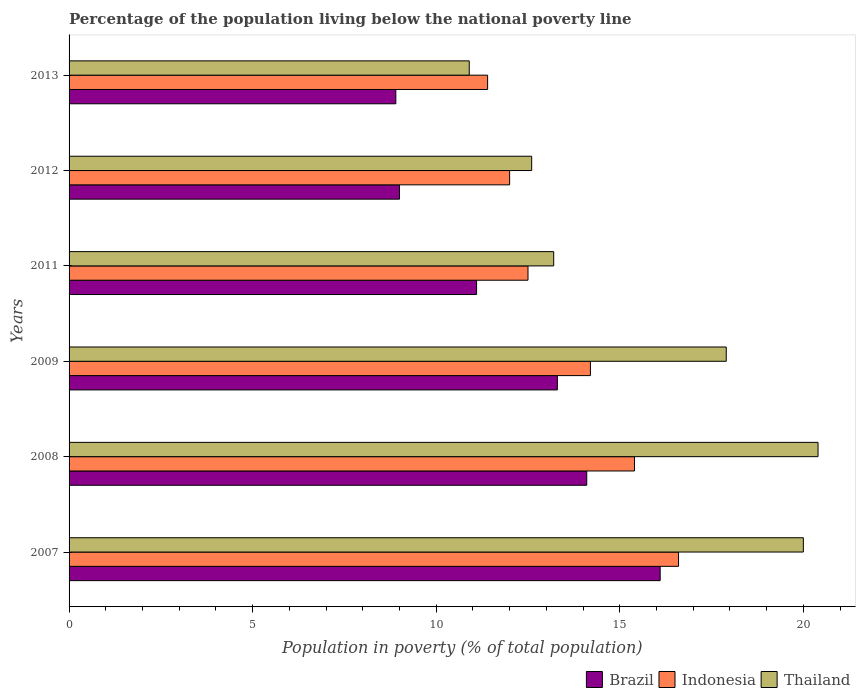Are the number of bars per tick equal to the number of legend labels?
Provide a succinct answer. Yes. How many bars are there on the 1st tick from the bottom?
Ensure brevity in your answer.  3. In how many cases, is the number of bars for a given year not equal to the number of legend labels?
Your response must be concise. 0. What is the percentage of the population living below the national poverty line in Thailand in 2009?
Make the answer very short. 17.9. Across all years, what is the maximum percentage of the population living below the national poverty line in Brazil?
Your answer should be very brief. 16.1. Across all years, what is the minimum percentage of the population living below the national poverty line in Indonesia?
Offer a very short reply. 11.4. In which year was the percentage of the population living below the national poverty line in Brazil minimum?
Provide a short and direct response. 2013. What is the difference between the percentage of the population living below the national poverty line in Indonesia in 2009 and that in 2012?
Ensure brevity in your answer.  2.2. What is the difference between the percentage of the population living below the national poverty line in Brazil in 2008 and the percentage of the population living below the national poverty line in Indonesia in 2012?
Your answer should be compact. 2.1. What is the average percentage of the population living below the national poverty line in Brazil per year?
Your answer should be very brief. 12.08. What is the ratio of the percentage of the population living below the national poverty line in Thailand in 2007 to that in 2008?
Offer a very short reply. 0.98. Is the percentage of the population living below the national poverty line in Thailand in 2012 less than that in 2013?
Give a very brief answer. No. What is the difference between the highest and the second highest percentage of the population living below the national poverty line in Thailand?
Provide a short and direct response. 0.4. What is the difference between the highest and the lowest percentage of the population living below the national poverty line in Thailand?
Give a very brief answer. 9.5. What does the 2nd bar from the top in 2012 represents?
Ensure brevity in your answer.  Indonesia. What does the 3rd bar from the bottom in 2008 represents?
Keep it short and to the point. Thailand. Is it the case that in every year, the sum of the percentage of the population living below the national poverty line in Brazil and percentage of the population living below the national poverty line in Thailand is greater than the percentage of the population living below the national poverty line in Indonesia?
Your answer should be compact. Yes. How many bars are there?
Your answer should be compact. 18. How many years are there in the graph?
Your answer should be very brief. 6. What is the difference between two consecutive major ticks on the X-axis?
Keep it short and to the point. 5. Are the values on the major ticks of X-axis written in scientific E-notation?
Ensure brevity in your answer.  No. What is the title of the graph?
Offer a very short reply. Percentage of the population living below the national poverty line. What is the label or title of the X-axis?
Your answer should be compact. Population in poverty (% of total population). What is the label or title of the Y-axis?
Your answer should be compact. Years. What is the Population in poverty (% of total population) in Indonesia in 2007?
Provide a short and direct response. 16.6. What is the Population in poverty (% of total population) of Thailand in 2008?
Keep it short and to the point. 20.4. What is the Population in poverty (% of total population) of Brazil in 2009?
Offer a very short reply. 13.3. What is the Population in poverty (% of total population) in Brazil in 2011?
Give a very brief answer. 11.1. What is the Population in poverty (% of total population) in Indonesia in 2011?
Provide a succinct answer. 12.5. What is the Population in poverty (% of total population) of Thailand in 2011?
Your answer should be compact. 13.2. What is the Population in poverty (% of total population) in Brazil in 2012?
Your answer should be compact. 9. What is the Population in poverty (% of total population) in Indonesia in 2012?
Ensure brevity in your answer.  12. What is the Population in poverty (% of total population) in Thailand in 2012?
Offer a very short reply. 12.6. Across all years, what is the maximum Population in poverty (% of total population) of Brazil?
Keep it short and to the point. 16.1. Across all years, what is the maximum Population in poverty (% of total population) of Thailand?
Provide a short and direct response. 20.4. Across all years, what is the minimum Population in poverty (% of total population) of Brazil?
Your answer should be compact. 8.9. What is the total Population in poverty (% of total population) of Brazil in the graph?
Keep it short and to the point. 72.5. What is the total Population in poverty (% of total population) in Indonesia in the graph?
Your answer should be compact. 82.1. What is the total Population in poverty (% of total population) in Thailand in the graph?
Offer a very short reply. 95. What is the difference between the Population in poverty (% of total population) of Brazil in 2007 and that in 2008?
Give a very brief answer. 2. What is the difference between the Population in poverty (% of total population) in Indonesia in 2007 and that in 2008?
Give a very brief answer. 1.2. What is the difference between the Population in poverty (% of total population) in Brazil in 2007 and that in 2009?
Your response must be concise. 2.8. What is the difference between the Population in poverty (% of total population) in Indonesia in 2007 and that in 2009?
Provide a succinct answer. 2.4. What is the difference between the Population in poverty (% of total population) in Thailand in 2007 and that in 2009?
Offer a very short reply. 2.1. What is the difference between the Population in poverty (% of total population) in Brazil in 2007 and that in 2011?
Ensure brevity in your answer.  5. What is the difference between the Population in poverty (% of total population) in Indonesia in 2007 and that in 2011?
Keep it short and to the point. 4.1. What is the difference between the Population in poverty (% of total population) in Indonesia in 2007 and that in 2012?
Your answer should be very brief. 4.6. What is the difference between the Population in poverty (% of total population) in Thailand in 2007 and that in 2012?
Your answer should be compact. 7.4. What is the difference between the Population in poverty (% of total population) in Brazil in 2008 and that in 2009?
Give a very brief answer. 0.8. What is the difference between the Population in poverty (% of total population) in Brazil in 2008 and that in 2012?
Make the answer very short. 5.1. What is the difference between the Population in poverty (% of total population) of Indonesia in 2008 and that in 2012?
Offer a terse response. 3.4. What is the difference between the Population in poverty (% of total population) of Thailand in 2008 and that in 2012?
Offer a very short reply. 7.8. What is the difference between the Population in poverty (% of total population) in Brazil in 2008 and that in 2013?
Your answer should be compact. 5.2. What is the difference between the Population in poverty (% of total population) of Thailand in 2008 and that in 2013?
Make the answer very short. 9.5. What is the difference between the Population in poverty (% of total population) of Indonesia in 2009 and that in 2011?
Your response must be concise. 1.7. What is the difference between the Population in poverty (% of total population) of Brazil in 2009 and that in 2013?
Make the answer very short. 4.4. What is the difference between the Population in poverty (% of total population) in Indonesia in 2009 and that in 2013?
Keep it short and to the point. 2.8. What is the difference between the Population in poverty (% of total population) in Thailand in 2009 and that in 2013?
Your answer should be very brief. 7. What is the difference between the Population in poverty (% of total population) in Brazil in 2011 and that in 2013?
Provide a short and direct response. 2.2. What is the difference between the Population in poverty (% of total population) in Indonesia in 2011 and that in 2013?
Make the answer very short. 1.1. What is the difference between the Population in poverty (% of total population) of Indonesia in 2012 and that in 2013?
Ensure brevity in your answer.  0.6. What is the difference between the Population in poverty (% of total population) of Thailand in 2012 and that in 2013?
Provide a short and direct response. 1.7. What is the difference between the Population in poverty (% of total population) in Brazil in 2007 and the Population in poverty (% of total population) in Indonesia in 2008?
Your answer should be very brief. 0.7. What is the difference between the Population in poverty (% of total population) in Indonesia in 2007 and the Population in poverty (% of total population) in Thailand in 2008?
Make the answer very short. -3.8. What is the difference between the Population in poverty (% of total population) in Indonesia in 2007 and the Population in poverty (% of total population) in Thailand in 2009?
Your response must be concise. -1.3. What is the difference between the Population in poverty (% of total population) of Brazil in 2007 and the Population in poverty (% of total population) of Thailand in 2011?
Provide a succinct answer. 2.9. What is the difference between the Population in poverty (% of total population) of Brazil in 2007 and the Population in poverty (% of total population) of Thailand in 2012?
Ensure brevity in your answer.  3.5. What is the difference between the Population in poverty (% of total population) in Brazil in 2008 and the Population in poverty (% of total population) in Thailand in 2009?
Offer a very short reply. -3.8. What is the difference between the Population in poverty (% of total population) in Indonesia in 2008 and the Population in poverty (% of total population) in Thailand in 2011?
Keep it short and to the point. 2.2. What is the difference between the Population in poverty (% of total population) of Brazil in 2008 and the Population in poverty (% of total population) of Thailand in 2012?
Make the answer very short. 1.5. What is the difference between the Population in poverty (% of total population) of Brazil in 2008 and the Population in poverty (% of total population) of Thailand in 2013?
Provide a succinct answer. 3.2. What is the difference between the Population in poverty (% of total population) of Brazil in 2009 and the Population in poverty (% of total population) of Indonesia in 2011?
Your response must be concise. 0.8. What is the difference between the Population in poverty (% of total population) in Brazil in 2009 and the Population in poverty (% of total population) in Thailand in 2011?
Your answer should be very brief. 0.1. What is the difference between the Population in poverty (% of total population) in Indonesia in 2009 and the Population in poverty (% of total population) in Thailand in 2011?
Offer a very short reply. 1. What is the difference between the Population in poverty (% of total population) in Indonesia in 2009 and the Population in poverty (% of total population) in Thailand in 2012?
Offer a terse response. 1.6. What is the difference between the Population in poverty (% of total population) of Indonesia in 2009 and the Population in poverty (% of total population) of Thailand in 2013?
Your answer should be very brief. 3.3. What is the difference between the Population in poverty (% of total population) in Brazil in 2011 and the Population in poverty (% of total population) in Thailand in 2012?
Keep it short and to the point. -1.5. What is the difference between the Population in poverty (% of total population) in Brazil in 2011 and the Population in poverty (% of total population) in Indonesia in 2013?
Your answer should be compact. -0.3. What is the difference between the Population in poverty (% of total population) of Brazil in 2011 and the Population in poverty (% of total population) of Thailand in 2013?
Offer a very short reply. 0.2. What is the difference between the Population in poverty (% of total population) of Indonesia in 2011 and the Population in poverty (% of total population) of Thailand in 2013?
Ensure brevity in your answer.  1.6. What is the difference between the Population in poverty (% of total population) of Brazil in 2012 and the Population in poverty (% of total population) of Indonesia in 2013?
Keep it short and to the point. -2.4. What is the difference between the Population in poverty (% of total population) in Brazil in 2012 and the Population in poverty (% of total population) in Thailand in 2013?
Ensure brevity in your answer.  -1.9. What is the difference between the Population in poverty (% of total population) in Indonesia in 2012 and the Population in poverty (% of total population) in Thailand in 2013?
Provide a succinct answer. 1.1. What is the average Population in poverty (% of total population) of Brazil per year?
Your answer should be compact. 12.08. What is the average Population in poverty (% of total population) of Indonesia per year?
Make the answer very short. 13.68. What is the average Population in poverty (% of total population) of Thailand per year?
Keep it short and to the point. 15.83. In the year 2007, what is the difference between the Population in poverty (% of total population) in Brazil and Population in poverty (% of total population) in Indonesia?
Keep it short and to the point. -0.5. In the year 2008, what is the difference between the Population in poverty (% of total population) in Brazil and Population in poverty (% of total population) in Indonesia?
Provide a succinct answer. -1.3. In the year 2008, what is the difference between the Population in poverty (% of total population) of Brazil and Population in poverty (% of total population) of Thailand?
Ensure brevity in your answer.  -6.3. In the year 2009, what is the difference between the Population in poverty (% of total population) in Brazil and Population in poverty (% of total population) in Indonesia?
Provide a short and direct response. -0.9. In the year 2009, what is the difference between the Population in poverty (% of total population) of Brazil and Population in poverty (% of total population) of Thailand?
Offer a very short reply. -4.6. In the year 2009, what is the difference between the Population in poverty (% of total population) of Indonesia and Population in poverty (% of total population) of Thailand?
Keep it short and to the point. -3.7. In the year 2011, what is the difference between the Population in poverty (% of total population) of Brazil and Population in poverty (% of total population) of Indonesia?
Offer a very short reply. -1.4. In the year 2011, what is the difference between the Population in poverty (% of total population) of Indonesia and Population in poverty (% of total population) of Thailand?
Your response must be concise. -0.7. In the year 2012, what is the difference between the Population in poverty (% of total population) of Brazil and Population in poverty (% of total population) of Thailand?
Provide a short and direct response. -3.6. In the year 2012, what is the difference between the Population in poverty (% of total population) of Indonesia and Population in poverty (% of total population) of Thailand?
Offer a terse response. -0.6. In the year 2013, what is the difference between the Population in poverty (% of total population) in Brazil and Population in poverty (% of total population) in Indonesia?
Your response must be concise. -2.5. In the year 2013, what is the difference between the Population in poverty (% of total population) of Brazil and Population in poverty (% of total population) of Thailand?
Give a very brief answer. -2. What is the ratio of the Population in poverty (% of total population) in Brazil in 2007 to that in 2008?
Offer a very short reply. 1.14. What is the ratio of the Population in poverty (% of total population) of Indonesia in 2007 to that in 2008?
Your answer should be compact. 1.08. What is the ratio of the Population in poverty (% of total population) in Thailand in 2007 to that in 2008?
Offer a terse response. 0.98. What is the ratio of the Population in poverty (% of total population) in Brazil in 2007 to that in 2009?
Your answer should be very brief. 1.21. What is the ratio of the Population in poverty (% of total population) of Indonesia in 2007 to that in 2009?
Ensure brevity in your answer.  1.17. What is the ratio of the Population in poverty (% of total population) of Thailand in 2007 to that in 2009?
Give a very brief answer. 1.12. What is the ratio of the Population in poverty (% of total population) of Brazil in 2007 to that in 2011?
Give a very brief answer. 1.45. What is the ratio of the Population in poverty (% of total population) in Indonesia in 2007 to that in 2011?
Your answer should be compact. 1.33. What is the ratio of the Population in poverty (% of total population) of Thailand in 2007 to that in 2011?
Ensure brevity in your answer.  1.52. What is the ratio of the Population in poverty (% of total population) in Brazil in 2007 to that in 2012?
Give a very brief answer. 1.79. What is the ratio of the Population in poverty (% of total population) in Indonesia in 2007 to that in 2012?
Give a very brief answer. 1.38. What is the ratio of the Population in poverty (% of total population) in Thailand in 2007 to that in 2012?
Your answer should be compact. 1.59. What is the ratio of the Population in poverty (% of total population) in Brazil in 2007 to that in 2013?
Give a very brief answer. 1.81. What is the ratio of the Population in poverty (% of total population) of Indonesia in 2007 to that in 2013?
Ensure brevity in your answer.  1.46. What is the ratio of the Population in poverty (% of total population) in Thailand in 2007 to that in 2013?
Your response must be concise. 1.83. What is the ratio of the Population in poverty (% of total population) of Brazil in 2008 to that in 2009?
Your answer should be compact. 1.06. What is the ratio of the Population in poverty (% of total population) in Indonesia in 2008 to that in 2009?
Your response must be concise. 1.08. What is the ratio of the Population in poverty (% of total population) in Thailand in 2008 to that in 2009?
Offer a terse response. 1.14. What is the ratio of the Population in poverty (% of total population) in Brazil in 2008 to that in 2011?
Provide a succinct answer. 1.27. What is the ratio of the Population in poverty (% of total population) of Indonesia in 2008 to that in 2011?
Make the answer very short. 1.23. What is the ratio of the Population in poverty (% of total population) in Thailand in 2008 to that in 2011?
Offer a terse response. 1.55. What is the ratio of the Population in poverty (% of total population) of Brazil in 2008 to that in 2012?
Ensure brevity in your answer.  1.57. What is the ratio of the Population in poverty (% of total population) in Indonesia in 2008 to that in 2012?
Provide a succinct answer. 1.28. What is the ratio of the Population in poverty (% of total population) in Thailand in 2008 to that in 2012?
Your answer should be very brief. 1.62. What is the ratio of the Population in poverty (% of total population) of Brazil in 2008 to that in 2013?
Your answer should be compact. 1.58. What is the ratio of the Population in poverty (% of total population) of Indonesia in 2008 to that in 2013?
Your response must be concise. 1.35. What is the ratio of the Population in poverty (% of total population) of Thailand in 2008 to that in 2013?
Your answer should be very brief. 1.87. What is the ratio of the Population in poverty (% of total population) in Brazil in 2009 to that in 2011?
Your answer should be compact. 1.2. What is the ratio of the Population in poverty (% of total population) of Indonesia in 2009 to that in 2011?
Provide a short and direct response. 1.14. What is the ratio of the Population in poverty (% of total population) in Thailand in 2009 to that in 2011?
Your response must be concise. 1.36. What is the ratio of the Population in poverty (% of total population) in Brazil in 2009 to that in 2012?
Make the answer very short. 1.48. What is the ratio of the Population in poverty (% of total population) in Indonesia in 2009 to that in 2012?
Your answer should be compact. 1.18. What is the ratio of the Population in poverty (% of total population) of Thailand in 2009 to that in 2012?
Your response must be concise. 1.42. What is the ratio of the Population in poverty (% of total population) in Brazil in 2009 to that in 2013?
Offer a terse response. 1.49. What is the ratio of the Population in poverty (% of total population) of Indonesia in 2009 to that in 2013?
Ensure brevity in your answer.  1.25. What is the ratio of the Population in poverty (% of total population) in Thailand in 2009 to that in 2013?
Your response must be concise. 1.64. What is the ratio of the Population in poverty (% of total population) of Brazil in 2011 to that in 2012?
Provide a short and direct response. 1.23. What is the ratio of the Population in poverty (% of total population) of Indonesia in 2011 to that in 2012?
Provide a short and direct response. 1.04. What is the ratio of the Population in poverty (% of total population) of Thailand in 2011 to that in 2012?
Make the answer very short. 1.05. What is the ratio of the Population in poverty (% of total population) of Brazil in 2011 to that in 2013?
Provide a succinct answer. 1.25. What is the ratio of the Population in poverty (% of total population) of Indonesia in 2011 to that in 2013?
Provide a succinct answer. 1.1. What is the ratio of the Population in poverty (% of total population) in Thailand in 2011 to that in 2013?
Provide a succinct answer. 1.21. What is the ratio of the Population in poverty (% of total population) in Brazil in 2012 to that in 2013?
Provide a short and direct response. 1.01. What is the ratio of the Population in poverty (% of total population) in Indonesia in 2012 to that in 2013?
Your answer should be very brief. 1.05. What is the ratio of the Population in poverty (% of total population) of Thailand in 2012 to that in 2013?
Give a very brief answer. 1.16. What is the difference between the highest and the second highest Population in poverty (% of total population) of Indonesia?
Provide a succinct answer. 1.2. What is the difference between the highest and the second highest Population in poverty (% of total population) of Thailand?
Offer a very short reply. 0.4. What is the difference between the highest and the lowest Population in poverty (% of total population) of Brazil?
Make the answer very short. 7.2. What is the difference between the highest and the lowest Population in poverty (% of total population) in Indonesia?
Give a very brief answer. 5.2. What is the difference between the highest and the lowest Population in poverty (% of total population) of Thailand?
Your response must be concise. 9.5. 